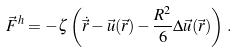<formula> <loc_0><loc_0><loc_500><loc_500>\vec { F } ^ { h } & = - \zeta \left ( \dot { \vec { r } } - \vec { u } ( \vec { r } ) - \frac { R ^ { 2 } } { 6 } \Delta \vec { u } ( \vec { r } ) \right ) \, .</formula> 